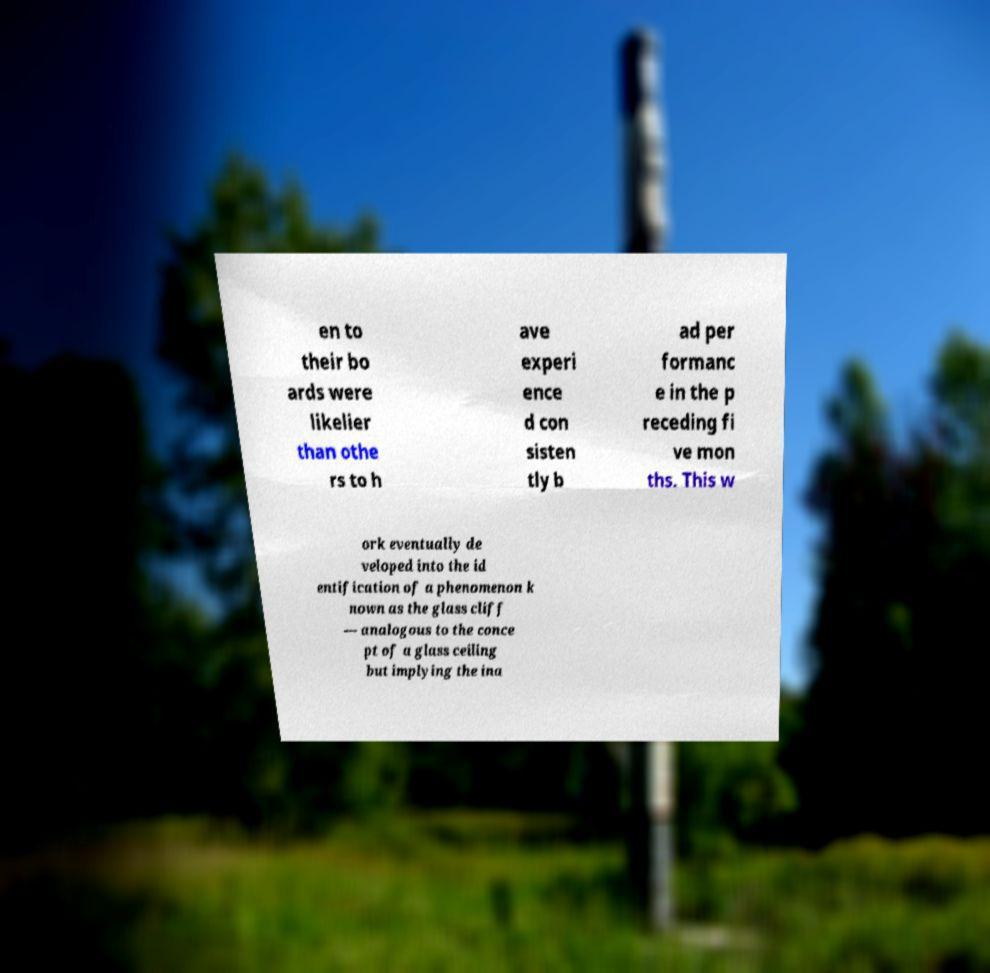Can you accurately transcribe the text from the provided image for me? en to their bo ards were likelier than othe rs to h ave experi ence d con sisten tly b ad per formanc e in the p receding fi ve mon ths. This w ork eventually de veloped into the id entification of a phenomenon k nown as the glass cliff — analogous to the conce pt of a glass ceiling but implying the ina 